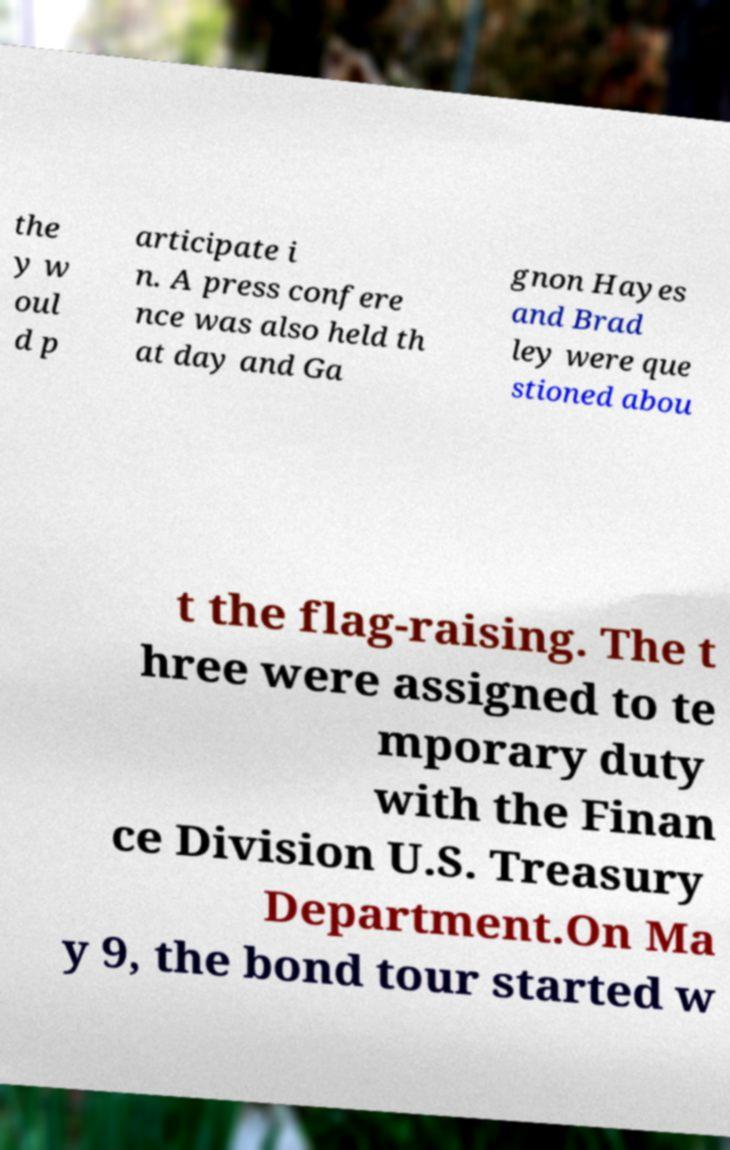Can you read and provide the text displayed in the image?This photo seems to have some interesting text. Can you extract and type it out for me? the y w oul d p articipate i n. A press confere nce was also held th at day and Ga gnon Hayes and Brad ley were que stioned abou t the flag-raising. The t hree were assigned to te mporary duty with the Finan ce Division U.S. Treasury Department.On Ma y 9, the bond tour started w 